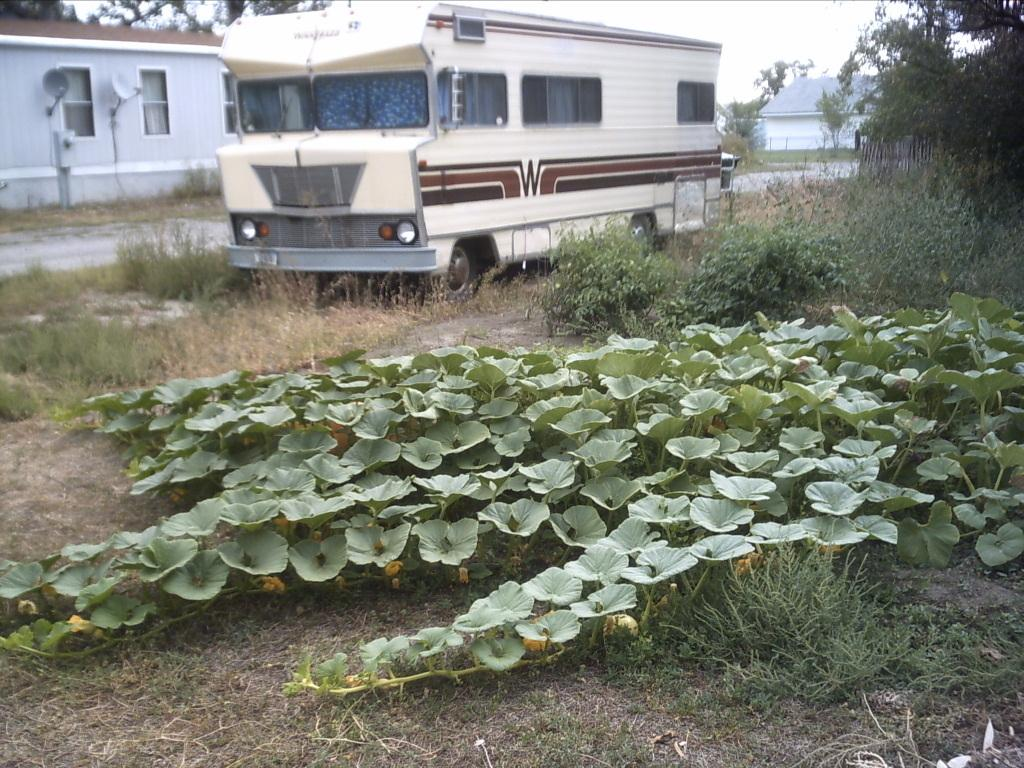What is the main subject of the image? The main subject of the image is a truck. What is the current state of the truck in the image? The truck is parked in the image. What type of natural elements can be seen in the backdrop of the image? There are plants and trees in the backdrop of the image. What type of man-made structures can be seen in the backdrop of the image? There are buildings in the backdrop of the image. Can you tell me how many times the wool comb is used in the image? There is no wool comb present in the image, so it cannot be used or counted. 